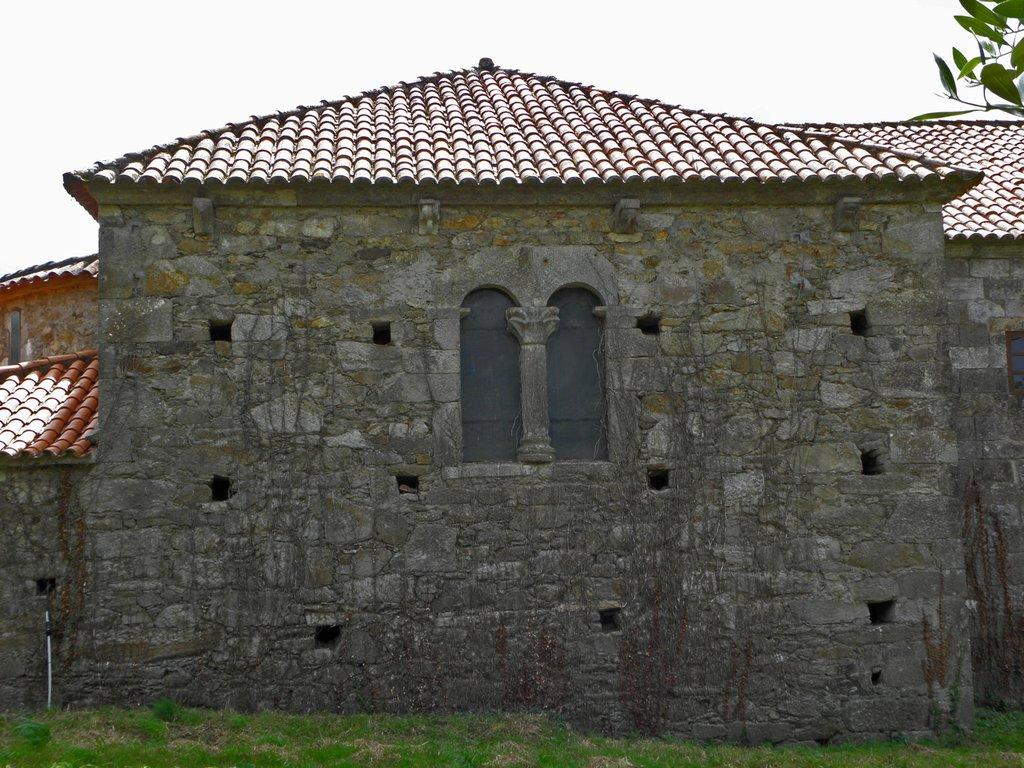What type of structure is present in the image? There is a house in the image. What can be seen on the ground in the image? The ground is visible in the image and has some grass. Can you describe the white colored object in the image? There is a white colored object in the image, but its specific nature is not clear from the facts provided. What is present in the top right corner of the image? There are leaves in the top right corner of the image. What part of the natural environment is visible in the image? The sky is visible in the image. What type of force is being applied to the bun in the image? There is no bun present in the image, so no force can be applied to it. 